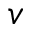<formula> <loc_0><loc_0><loc_500><loc_500>v</formula> 